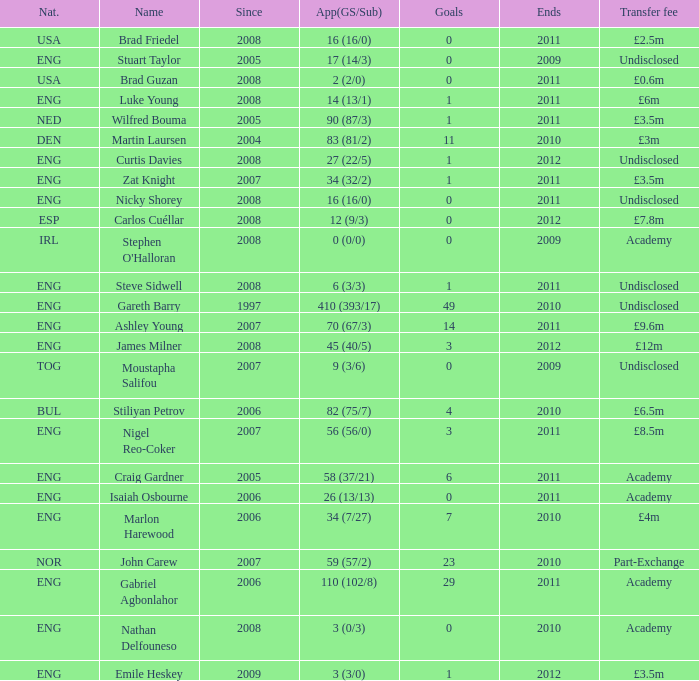What is the greatest goals for Curtis Davies if ends is greater than 2012? None. 